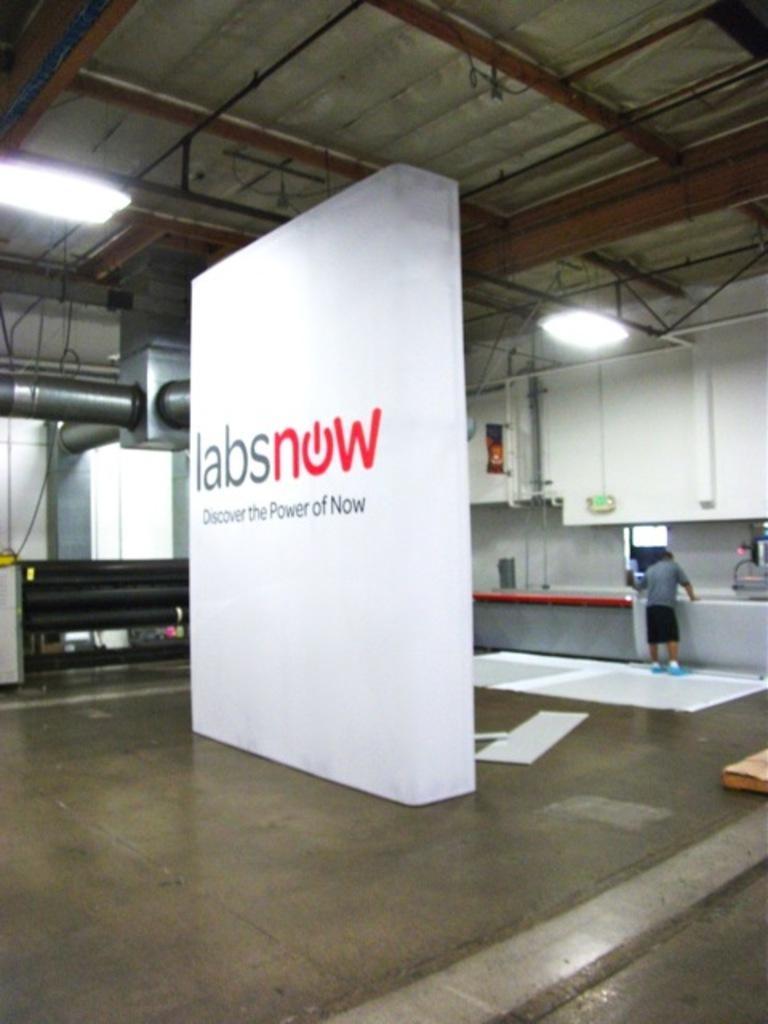Describe this image in one or two sentences. This is an inner view of a building containing a banner with some text on it, some papers on the floor, a person standing beside a table, some pipes, a wall and a roof with some ceiling lights. 